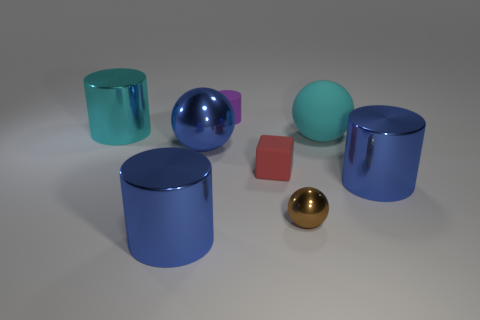Add 2 large balls. How many objects exist? 10 Subtract all blocks. How many objects are left? 7 Add 5 big blue spheres. How many big blue spheres exist? 6 Subtract 2 blue cylinders. How many objects are left? 6 Subtract all big brown shiny spheres. Subtract all large cyan metal cylinders. How many objects are left? 7 Add 6 matte things. How many matte things are left? 9 